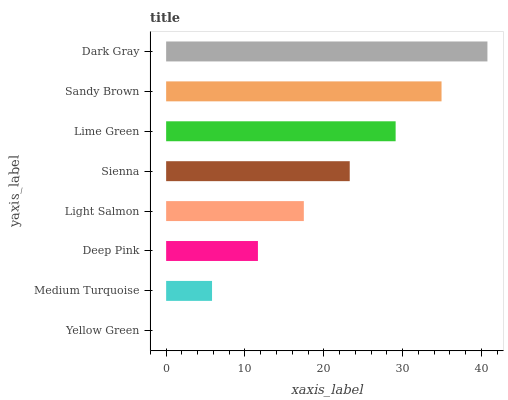Is Yellow Green the minimum?
Answer yes or no. Yes. Is Dark Gray the maximum?
Answer yes or no. Yes. Is Medium Turquoise the minimum?
Answer yes or no. No. Is Medium Turquoise the maximum?
Answer yes or no. No. Is Medium Turquoise greater than Yellow Green?
Answer yes or no. Yes. Is Yellow Green less than Medium Turquoise?
Answer yes or no. Yes. Is Yellow Green greater than Medium Turquoise?
Answer yes or no. No. Is Medium Turquoise less than Yellow Green?
Answer yes or no. No. Is Sienna the high median?
Answer yes or no. Yes. Is Light Salmon the low median?
Answer yes or no. Yes. Is Yellow Green the high median?
Answer yes or no. No. Is Dark Gray the low median?
Answer yes or no. No. 